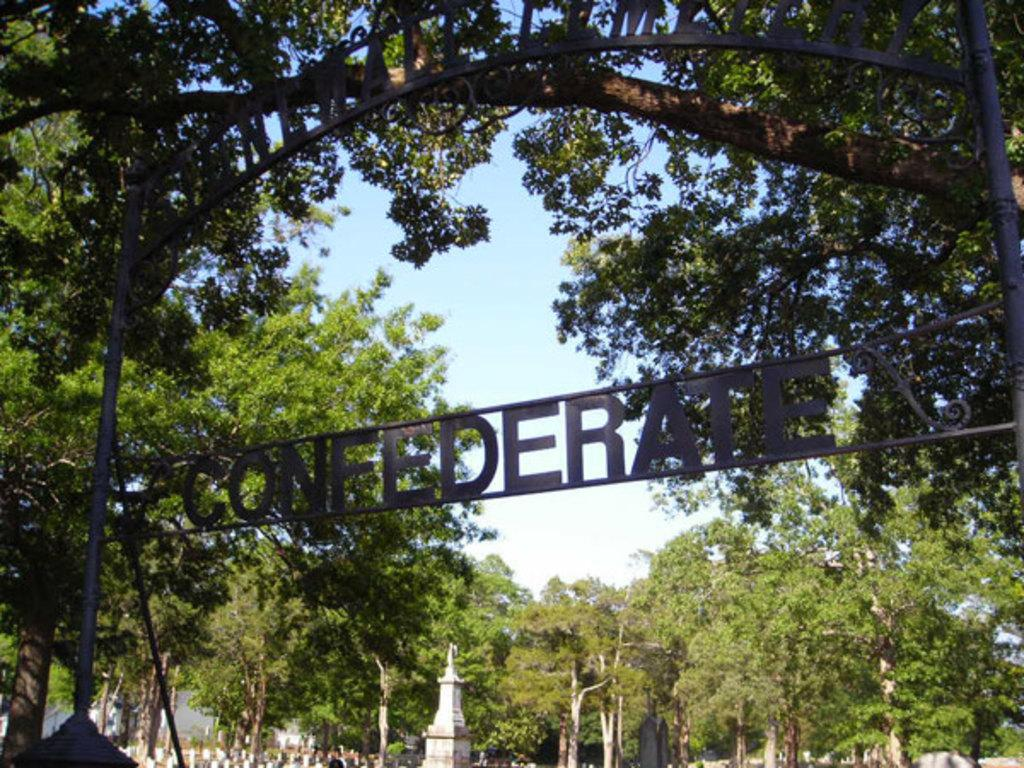What can be seen on the boards in the image? There are boards with text in the image. What type of natural elements are present in the image? There are trees in the image. What structures can be seen in the image? There are poles and towers in the image. What type of man-made barrier is visible in the image? There is a wall in the image. What is visible in the background of the image? The sky is visible in the background of the image. What type of creature can be seen interacting with the wall in the image? There is no creature present or interacting with the wall in the image. 